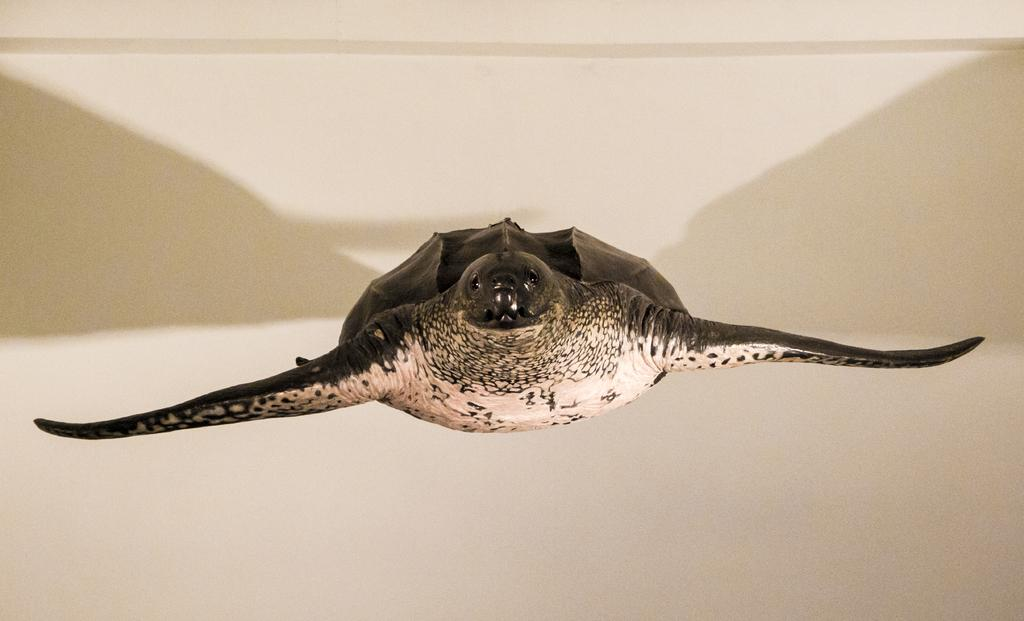What is the main subject in the center of the image? There is a turtle-like object in the center of the image. Can you describe any other items visible in the image? There are other items visible in the background of the image. How much does the toothbrush weigh in the image? There is no toothbrush present in the image, so it is not possible to determine its weight. 